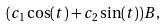Convert formula to latex. <formula><loc_0><loc_0><loc_500><loc_500>( c _ { 1 } \cos ( t ) + c _ { 2 } \sin ( t ) ) B ,</formula> 